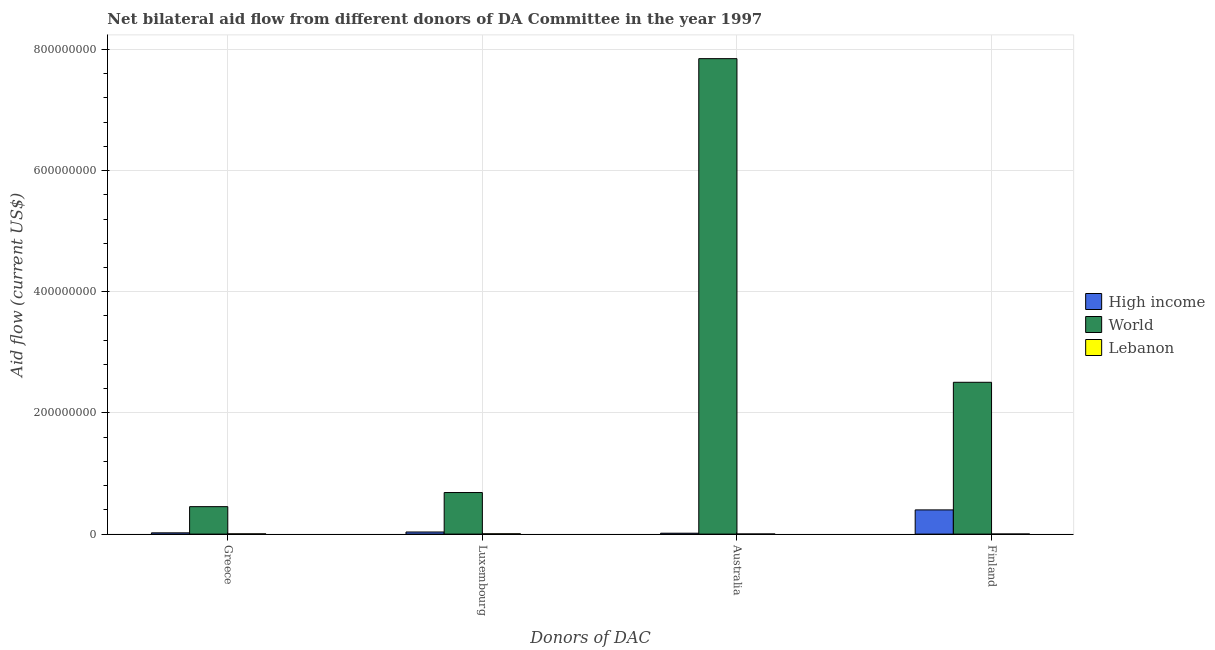How many groups of bars are there?
Provide a short and direct response. 4. How many bars are there on the 4th tick from the left?
Keep it short and to the point. 3. What is the label of the 3rd group of bars from the left?
Provide a succinct answer. Australia. What is the amount of aid given by luxembourg in World?
Give a very brief answer. 6.86e+07. Across all countries, what is the maximum amount of aid given by australia?
Your response must be concise. 7.85e+08. Across all countries, what is the minimum amount of aid given by australia?
Your answer should be compact. 1.50e+05. In which country was the amount of aid given by finland maximum?
Provide a short and direct response. World. In which country was the amount of aid given by greece minimum?
Provide a short and direct response. Lebanon. What is the total amount of aid given by australia in the graph?
Provide a succinct answer. 7.86e+08. What is the difference between the amount of aid given by greece in World and that in Lebanon?
Provide a short and direct response. 4.49e+07. What is the difference between the amount of aid given by australia in Lebanon and the amount of aid given by greece in World?
Offer a very short reply. -4.52e+07. What is the average amount of aid given by greece per country?
Provide a short and direct response. 1.59e+07. What is the difference between the amount of aid given by luxembourg and amount of aid given by finland in High income?
Your answer should be very brief. -3.65e+07. What is the ratio of the amount of aid given by australia in Lebanon to that in High income?
Provide a succinct answer. 0.1. Is the amount of aid given by luxembourg in World less than that in Lebanon?
Provide a short and direct response. No. What is the difference between the highest and the second highest amount of aid given by australia?
Keep it short and to the point. 7.83e+08. What is the difference between the highest and the lowest amount of aid given by luxembourg?
Make the answer very short. 6.81e+07. In how many countries, is the amount of aid given by australia greater than the average amount of aid given by australia taken over all countries?
Offer a terse response. 1. What does the 3rd bar from the right in Luxembourg represents?
Offer a very short reply. High income. Is it the case that in every country, the sum of the amount of aid given by greece and amount of aid given by luxembourg is greater than the amount of aid given by australia?
Offer a very short reply. No. How many bars are there?
Offer a terse response. 12. Are all the bars in the graph horizontal?
Provide a short and direct response. No. Where does the legend appear in the graph?
Keep it short and to the point. Center right. How many legend labels are there?
Provide a succinct answer. 3. How are the legend labels stacked?
Keep it short and to the point. Vertical. What is the title of the graph?
Offer a terse response. Net bilateral aid flow from different donors of DA Committee in the year 1997. Does "Central African Republic" appear as one of the legend labels in the graph?
Provide a short and direct response. No. What is the label or title of the X-axis?
Provide a short and direct response. Donors of DAC. What is the label or title of the Y-axis?
Give a very brief answer. Aid flow (current US$). What is the Aid flow (current US$) in High income in Greece?
Your response must be concise. 2.08e+06. What is the Aid flow (current US$) in World in Greece?
Provide a succinct answer. 4.53e+07. What is the Aid flow (current US$) of Lebanon in Greece?
Make the answer very short. 3.80e+05. What is the Aid flow (current US$) in High income in Luxembourg?
Make the answer very short. 3.47e+06. What is the Aid flow (current US$) in World in Luxembourg?
Your answer should be very brief. 6.86e+07. What is the Aid flow (current US$) in High income in Australia?
Offer a very short reply. 1.48e+06. What is the Aid flow (current US$) of World in Australia?
Provide a short and direct response. 7.85e+08. What is the Aid flow (current US$) in High income in Finland?
Provide a short and direct response. 3.99e+07. What is the Aid flow (current US$) of World in Finland?
Give a very brief answer. 2.51e+08. Across all Donors of DAC, what is the maximum Aid flow (current US$) of High income?
Offer a terse response. 3.99e+07. Across all Donors of DAC, what is the maximum Aid flow (current US$) in World?
Your answer should be very brief. 7.85e+08. Across all Donors of DAC, what is the maximum Aid flow (current US$) in Lebanon?
Offer a terse response. 4.90e+05. Across all Donors of DAC, what is the minimum Aid flow (current US$) in High income?
Offer a terse response. 1.48e+06. Across all Donors of DAC, what is the minimum Aid flow (current US$) of World?
Make the answer very short. 4.53e+07. What is the total Aid flow (current US$) in High income in the graph?
Your response must be concise. 4.70e+07. What is the total Aid flow (current US$) in World in the graph?
Give a very brief answer. 1.15e+09. What is the total Aid flow (current US$) of Lebanon in the graph?
Give a very brief answer. 1.12e+06. What is the difference between the Aid flow (current US$) of High income in Greece and that in Luxembourg?
Offer a very short reply. -1.39e+06. What is the difference between the Aid flow (current US$) in World in Greece and that in Luxembourg?
Make the answer very short. -2.33e+07. What is the difference between the Aid flow (current US$) of Lebanon in Greece and that in Luxembourg?
Offer a very short reply. -1.10e+05. What is the difference between the Aid flow (current US$) of World in Greece and that in Australia?
Provide a succinct answer. -7.39e+08. What is the difference between the Aid flow (current US$) in High income in Greece and that in Finland?
Provide a succinct answer. -3.79e+07. What is the difference between the Aid flow (current US$) of World in Greece and that in Finland?
Your answer should be very brief. -2.05e+08. What is the difference between the Aid flow (current US$) of Lebanon in Greece and that in Finland?
Your response must be concise. 2.80e+05. What is the difference between the Aid flow (current US$) in High income in Luxembourg and that in Australia?
Keep it short and to the point. 1.99e+06. What is the difference between the Aid flow (current US$) of World in Luxembourg and that in Australia?
Provide a short and direct response. -7.16e+08. What is the difference between the Aid flow (current US$) in Lebanon in Luxembourg and that in Australia?
Your answer should be very brief. 3.40e+05. What is the difference between the Aid flow (current US$) in High income in Luxembourg and that in Finland?
Give a very brief answer. -3.65e+07. What is the difference between the Aid flow (current US$) of World in Luxembourg and that in Finland?
Offer a very short reply. -1.82e+08. What is the difference between the Aid flow (current US$) of Lebanon in Luxembourg and that in Finland?
Make the answer very short. 3.90e+05. What is the difference between the Aid flow (current US$) in High income in Australia and that in Finland?
Your answer should be very brief. -3.85e+07. What is the difference between the Aid flow (current US$) in World in Australia and that in Finland?
Ensure brevity in your answer.  5.34e+08. What is the difference between the Aid flow (current US$) of High income in Greece and the Aid flow (current US$) of World in Luxembourg?
Give a very brief answer. -6.65e+07. What is the difference between the Aid flow (current US$) of High income in Greece and the Aid flow (current US$) of Lebanon in Luxembourg?
Provide a succinct answer. 1.59e+06. What is the difference between the Aid flow (current US$) of World in Greece and the Aid flow (current US$) of Lebanon in Luxembourg?
Your answer should be compact. 4.48e+07. What is the difference between the Aid flow (current US$) of High income in Greece and the Aid flow (current US$) of World in Australia?
Your answer should be compact. -7.83e+08. What is the difference between the Aid flow (current US$) in High income in Greece and the Aid flow (current US$) in Lebanon in Australia?
Your response must be concise. 1.93e+06. What is the difference between the Aid flow (current US$) of World in Greece and the Aid flow (current US$) of Lebanon in Australia?
Offer a terse response. 4.52e+07. What is the difference between the Aid flow (current US$) of High income in Greece and the Aid flow (current US$) of World in Finland?
Provide a succinct answer. -2.48e+08. What is the difference between the Aid flow (current US$) in High income in Greece and the Aid flow (current US$) in Lebanon in Finland?
Your answer should be very brief. 1.98e+06. What is the difference between the Aid flow (current US$) in World in Greece and the Aid flow (current US$) in Lebanon in Finland?
Provide a short and direct response. 4.52e+07. What is the difference between the Aid flow (current US$) in High income in Luxembourg and the Aid flow (current US$) in World in Australia?
Offer a terse response. -7.81e+08. What is the difference between the Aid flow (current US$) in High income in Luxembourg and the Aid flow (current US$) in Lebanon in Australia?
Give a very brief answer. 3.32e+06. What is the difference between the Aid flow (current US$) in World in Luxembourg and the Aid flow (current US$) in Lebanon in Australia?
Your answer should be compact. 6.84e+07. What is the difference between the Aid flow (current US$) in High income in Luxembourg and the Aid flow (current US$) in World in Finland?
Provide a succinct answer. -2.47e+08. What is the difference between the Aid flow (current US$) in High income in Luxembourg and the Aid flow (current US$) in Lebanon in Finland?
Your response must be concise. 3.37e+06. What is the difference between the Aid flow (current US$) in World in Luxembourg and the Aid flow (current US$) in Lebanon in Finland?
Keep it short and to the point. 6.85e+07. What is the difference between the Aid flow (current US$) in High income in Australia and the Aid flow (current US$) in World in Finland?
Provide a succinct answer. -2.49e+08. What is the difference between the Aid flow (current US$) in High income in Australia and the Aid flow (current US$) in Lebanon in Finland?
Offer a very short reply. 1.38e+06. What is the difference between the Aid flow (current US$) of World in Australia and the Aid flow (current US$) of Lebanon in Finland?
Provide a short and direct response. 7.85e+08. What is the average Aid flow (current US$) in High income per Donors of DAC?
Provide a succinct answer. 1.17e+07. What is the average Aid flow (current US$) in World per Donors of DAC?
Provide a succinct answer. 2.87e+08. What is the average Aid flow (current US$) of Lebanon per Donors of DAC?
Offer a very short reply. 2.80e+05. What is the difference between the Aid flow (current US$) in High income and Aid flow (current US$) in World in Greece?
Your answer should be compact. -4.32e+07. What is the difference between the Aid flow (current US$) in High income and Aid flow (current US$) in Lebanon in Greece?
Your answer should be compact. 1.70e+06. What is the difference between the Aid flow (current US$) of World and Aid flow (current US$) of Lebanon in Greece?
Your answer should be compact. 4.49e+07. What is the difference between the Aid flow (current US$) of High income and Aid flow (current US$) of World in Luxembourg?
Offer a very short reply. -6.51e+07. What is the difference between the Aid flow (current US$) in High income and Aid flow (current US$) in Lebanon in Luxembourg?
Keep it short and to the point. 2.98e+06. What is the difference between the Aid flow (current US$) of World and Aid flow (current US$) of Lebanon in Luxembourg?
Make the answer very short. 6.81e+07. What is the difference between the Aid flow (current US$) in High income and Aid flow (current US$) in World in Australia?
Give a very brief answer. -7.83e+08. What is the difference between the Aid flow (current US$) of High income and Aid flow (current US$) of Lebanon in Australia?
Offer a terse response. 1.33e+06. What is the difference between the Aid flow (current US$) of World and Aid flow (current US$) of Lebanon in Australia?
Your response must be concise. 7.84e+08. What is the difference between the Aid flow (current US$) in High income and Aid flow (current US$) in World in Finland?
Provide a succinct answer. -2.11e+08. What is the difference between the Aid flow (current US$) in High income and Aid flow (current US$) in Lebanon in Finland?
Your answer should be very brief. 3.98e+07. What is the difference between the Aid flow (current US$) in World and Aid flow (current US$) in Lebanon in Finland?
Your answer should be compact. 2.50e+08. What is the ratio of the Aid flow (current US$) of High income in Greece to that in Luxembourg?
Keep it short and to the point. 0.6. What is the ratio of the Aid flow (current US$) of World in Greece to that in Luxembourg?
Offer a terse response. 0.66. What is the ratio of the Aid flow (current US$) of Lebanon in Greece to that in Luxembourg?
Keep it short and to the point. 0.78. What is the ratio of the Aid flow (current US$) in High income in Greece to that in Australia?
Your answer should be compact. 1.41. What is the ratio of the Aid flow (current US$) of World in Greece to that in Australia?
Your answer should be compact. 0.06. What is the ratio of the Aid flow (current US$) in Lebanon in Greece to that in Australia?
Offer a very short reply. 2.53. What is the ratio of the Aid flow (current US$) of High income in Greece to that in Finland?
Ensure brevity in your answer.  0.05. What is the ratio of the Aid flow (current US$) of World in Greece to that in Finland?
Make the answer very short. 0.18. What is the ratio of the Aid flow (current US$) of Lebanon in Greece to that in Finland?
Provide a succinct answer. 3.8. What is the ratio of the Aid flow (current US$) of High income in Luxembourg to that in Australia?
Your response must be concise. 2.34. What is the ratio of the Aid flow (current US$) of World in Luxembourg to that in Australia?
Your answer should be very brief. 0.09. What is the ratio of the Aid flow (current US$) of Lebanon in Luxembourg to that in Australia?
Keep it short and to the point. 3.27. What is the ratio of the Aid flow (current US$) in High income in Luxembourg to that in Finland?
Offer a very short reply. 0.09. What is the ratio of the Aid flow (current US$) in World in Luxembourg to that in Finland?
Give a very brief answer. 0.27. What is the ratio of the Aid flow (current US$) of Lebanon in Luxembourg to that in Finland?
Keep it short and to the point. 4.9. What is the ratio of the Aid flow (current US$) in High income in Australia to that in Finland?
Give a very brief answer. 0.04. What is the ratio of the Aid flow (current US$) of World in Australia to that in Finland?
Your answer should be compact. 3.13. What is the difference between the highest and the second highest Aid flow (current US$) of High income?
Provide a succinct answer. 3.65e+07. What is the difference between the highest and the second highest Aid flow (current US$) of World?
Ensure brevity in your answer.  5.34e+08. What is the difference between the highest and the lowest Aid flow (current US$) of High income?
Provide a short and direct response. 3.85e+07. What is the difference between the highest and the lowest Aid flow (current US$) of World?
Your answer should be very brief. 7.39e+08. 